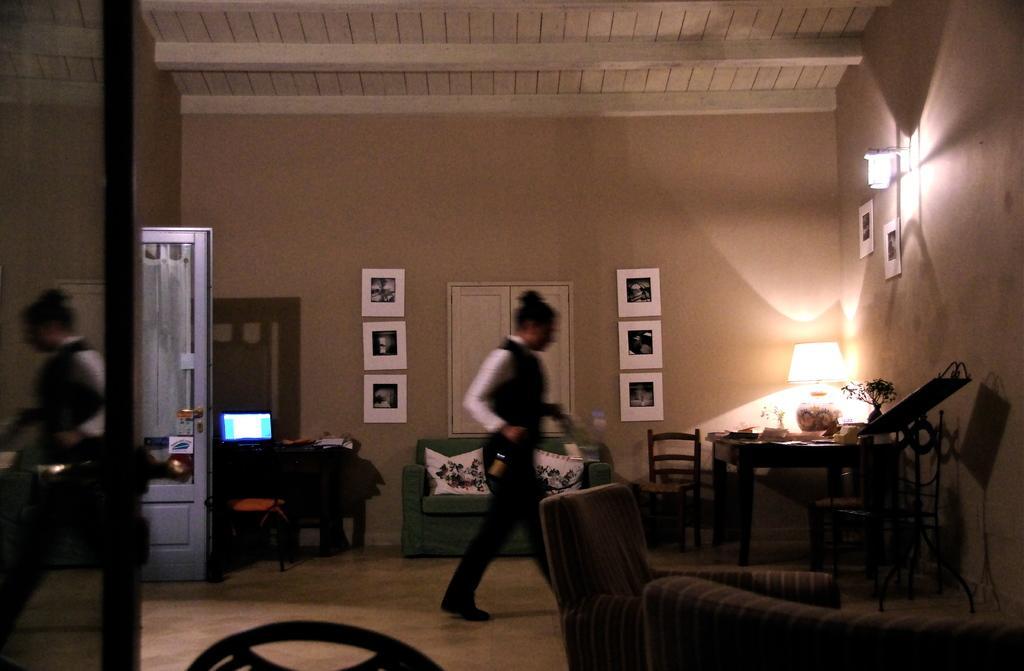In one or two sentences, can you explain what this image depicts? The picture is taken inside a room. There is a person in the room walking holding a bottle. There is a desk on which there is a laptop and a stool just in front of it. Beside it there is a couch and cushions on it. There is a table and chairs at the other corner of the room. On table there is a table lamp and flower vase. There is also another couch to the below right corner of the image. There is a wall lamp and photo frames hanged on the wall. On the left corner of the image the reflection of the person is seen.  